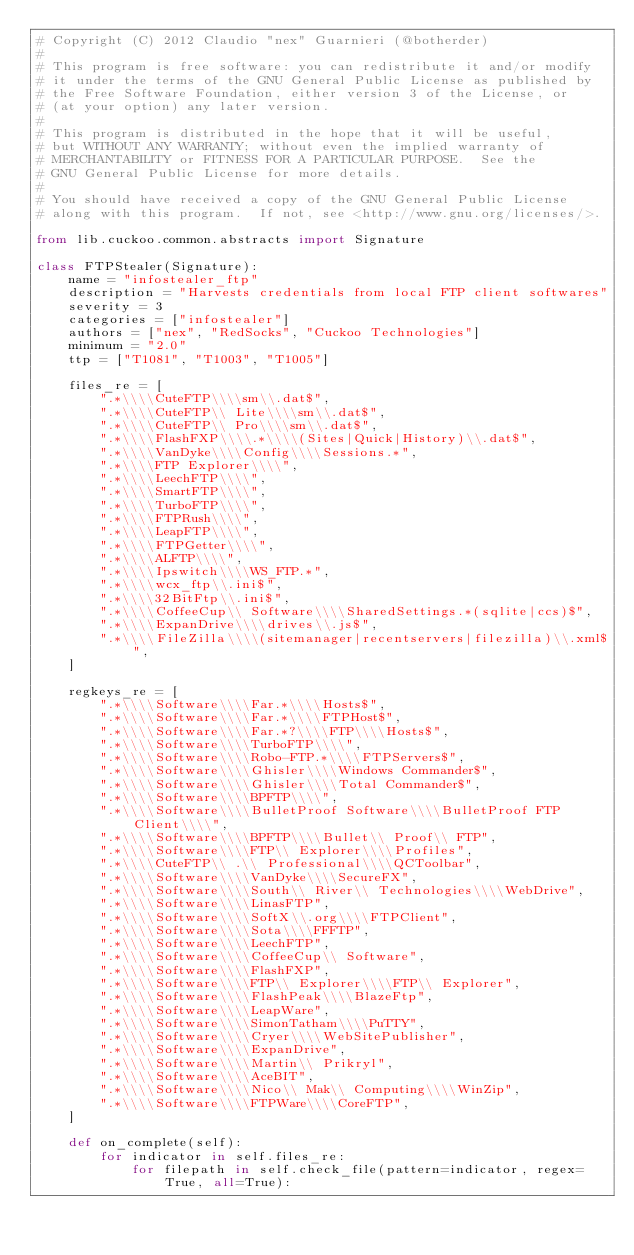Convert code to text. <code><loc_0><loc_0><loc_500><loc_500><_Python_># Copyright (C) 2012 Claudio "nex" Guarnieri (@botherder)
#
# This program is free software: you can redistribute it and/or modify
# it under the terms of the GNU General Public License as published by
# the Free Software Foundation, either version 3 of the License, or
# (at your option) any later version.
#
# This program is distributed in the hope that it will be useful,
# but WITHOUT ANY WARRANTY; without even the implied warranty of
# MERCHANTABILITY or FITNESS FOR A PARTICULAR PURPOSE.  See the
# GNU General Public License for more details.
#
# You should have received a copy of the GNU General Public License
# along with this program.  If not, see <http://www.gnu.org/licenses/>.

from lib.cuckoo.common.abstracts import Signature

class FTPStealer(Signature):
    name = "infostealer_ftp"
    description = "Harvests credentials from local FTP client softwares"
    severity = 3
    categories = ["infostealer"]
    authors = ["nex", "RedSocks", "Cuckoo Technologies"]
    minimum = "2.0"
    ttp = ["T1081", "T1003", "T1005"]

    files_re = [
        ".*\\\\CuteFTP\\\\sm\\.dat$",
        ".*\\\\CuteFTP\\ Lite\\\\sm\\.dat$",
        ".*\\\\CuteFTP\\ Pro\\\\sm\\.dat$",
        ".*\\\\FlashFXP\\\\.*\\\\(Sites|Quick|History)\\.dat$",
        ".*\\\\VanDyke\\\\Config\\\\Sessions.*",
        ".*\\\\FTP Explorer\\\\",
        ".*\\\\LeechFTP\\\\",
        ".*\\\\SmartFTP\\\\",
        ".*\\\\TurboFTP\\\\",
        ".*\\\\FTPRush\\\\",
        ".*\\\\LeapFTP\\\\",
        ".*\\\\FTPGetter\\\\",
        ".*\\\\ALFTP\\\\",
        ".*\\\\Ipswitch\\\\WS_FTP.*",
        ".*\\\\wcx_ftp\\.ini$",
        ".*\\\\32BitFtp\\.ini$",
        ".*\\\\CoffeeCup\\ Software\\\\SharedSettings.*(sqlite|ccs)$",
        ".*\\\\ExpanDrive\\\\drives\\.js$",
        ".*\\\\FileZilla\\\\(sitemanager|recentservers|filezilla)\\.xml$",
    ]

    regkeys_re = [
        ".*\\\\Software\\\\Far.*\\\\Hosts$",
        ".*\\\\Software\\\\Far.*\\\\FTPHost$",
        ".*\\\\Software\\\\Far.*?\\\\FTP\\\\Hosts$",
        ".*\\\\Software\\\\TurboFTP\\\\",
        ".*\\\\Software\\\\Robo-FTP.*\\\\FTPServers$",
        ".*\\\\Software\\\\Ghisler\\\\Windows Commander$",
        ".*\\\\Software\\\\Ghisler\\\\Total Commander$",
        ".*\\\\Software\\\\BPFTP\\\\",
        ".*\\\\Software\\\\BulletProof Software\\\\BulletProof FTP Client\\\\",
        ".*\\\\Software\\\\BPFTP\\\\Bullet\\ Proof\\ FTP",
        ".*\\\\Software\\\\FTP\\ Explorer\\\\Profiles",
        ".*\\\\CuteFTP\\ .\\ Professional\\\\QCToolbar",
        ".*\\\\Software\\\\VanDyke\\\\SecureFX",
        ".*\\\\Software\\\\South\\ River\\ Technologies\\\\WebDrive",
        ".*\\\\Software\\\\LinasFTP",
        ".*\\\\Software\\\\SoftX\\.org\\\\FTPClient",
        ".*\\\\Software\\\\Sota\\\\FFFTP",
        ".*\\\\Software\\\\LeechFTP",
        ".*\\\\Software\\\\CoffeeCup\\ Software",
        ".*\\\\Software\\\\FlashFXP",
        ".*\\\\Software\\\\FTP\\ Explorer\\\\FTP\\ Explorer",
        ".*\\\\Software\\\\FlashPeak\\\\BlazeFtp",
        ".*\\\\Software\\\\LeapWare",
        ".*\\\\Software\\\\SimonTatham\\\\PuTTY",
        ".*\\\\Software\\\\Cryer\\\\WebSitePublisher",
        ".*\\\\Software\\\\ExpanDrive",
        ".*\\\\Software\\\\Martin\\ Prikryl",
        ".*\\\\Software\\\\AceBIT",
        ".*\\\\Software\\\\Nico\\ Mak\\ Computing\\\\WinZip",
        ".*\\\\Software\\\\FTPWare\\\\CoreFTP",
    ]

    def on_complete(self):
        for indicator in self.files_re:
            for filepath in self.check_file(pattern=indicator, regex=True, all=True):</code> 